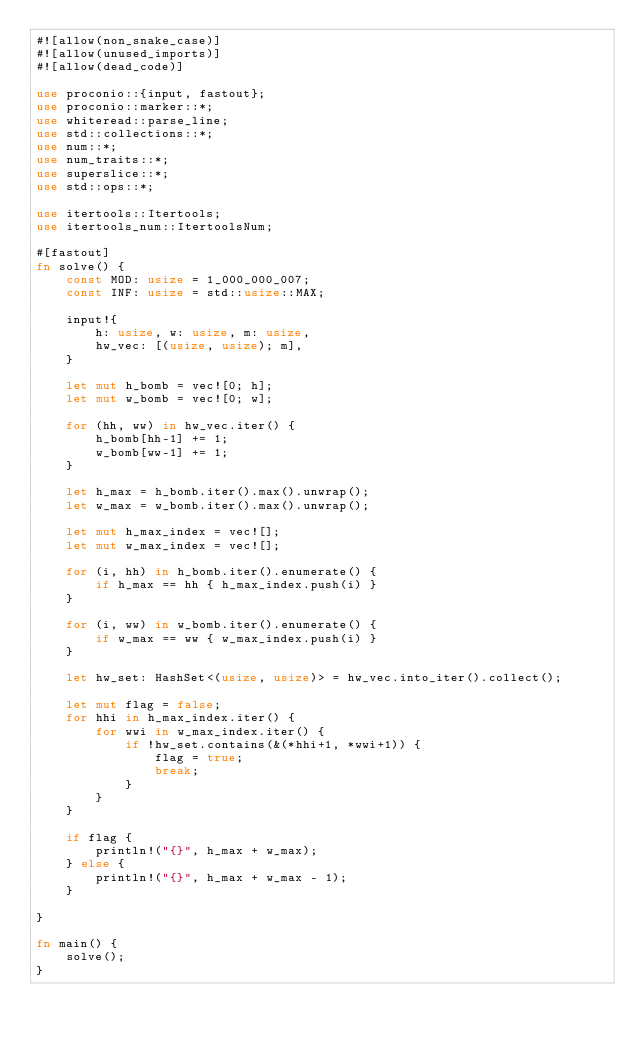Convert code to text. <code><loc_0><loc_0><loc_500><loc_500><_Rust_>#![allow(non_snake_case)]
#![allow(unused_imports)]
#![allow(dead_code)]
 
use proconio::{input, fastout};
use proconio::marker::*;
use whiteread::parse_line;
use std::collections::*;
use num::*;
use num_traits::*;
use superslice::*;
use std::ops::*;
 
use itertools::Itertools;
use itertools_num::ItertoolsNum;

#[fastout]
fn solve() {
    const MOD: usize = 1_000_000_007;
    const INF: usize = std::usize::MAX;

    input!{
        h: usize, w: usize, m: usize,
        hw_vec: [(usize, usize); m],
    }

    let mut h_bomb = vec![0; h];
    let mut w_bomb = vec![0; w];

    for (hh, ww) in hw_vec.iter() {
        h_bomb[hh-1] += 1;
        w_bomb[ww-1] += 1;
    }

    let h_max = h_bomb.iter().max().unwrap();
    let w_max = w_bomb.iter().max().unwrap();

    let mut h_max_index = vec![];
    let mut w_max_index = vec![];

    for (i, hh) in h_bomb.iter().enumerate() {
        if h_max == hh { h_max_index.push(i) }
    }

    for (i, ww) in w_bomb.iter().enumerate() {
        if w_max == ww { w_max_index.push(i) }
    }

    let hw_set: HashSet<(usize, usize)> = hw_vec.into_iter().collect();

    let mut flag = false;
    for hhi in h_max_index.iter() {
        for wwi in w_max_index.iter() {
            if !hw_set.contains(&(*hhi+1, *wwi+1)) {
                flag = true;
                break;
            }
        }
    }

    if flag {
        println!("{}", h_max + w_max);
    } else {
        println!("{}", h_max + w_max - 1);
    }
    
}

fn main() {
    solve();
}
</code> 